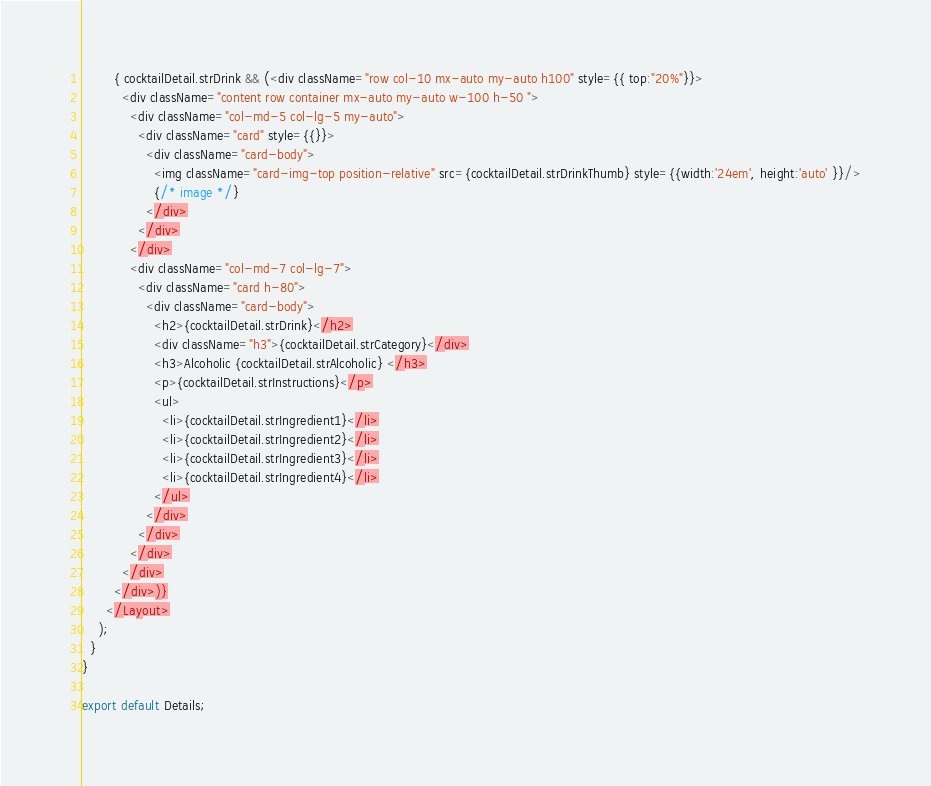<code> <loc_0><loc_0><loc_500><loc_500><_JavaScript_>        { cocktailDetail.strDrink && (<div className="row col-10 mx-auto my-auto h100" style={{ top:"20%"}}>
          <div className="content row container mx-auto my-auto w-100 h-50 ">
            <div className="col-md-5 col-lg-5 my-auto">
              <div className="card" style={{}}>
                <div className="card-body">
                  <img className="card-img-top position-relative" src={cocktailDetail.strDrinkThumb} style={{width:'24em', height:'auto' }}/>
                  {/* image */}
                </div>
              </div>
            </div>
            <div className="col-md-7 col-lg-7">
              <div className="card h-80">
                <div className="card-body">
                  <h2>{cocktailDetail.strDrink}</h2>
                  <div className="h3">{cocktailDetail.strCategory}</div>
                  <h3>Alcoholic {cocktailDetail.strAlcoholic} </h3>
                  <p>{cocktailDetail.strInstructions}</p>
                  <ul>
                    <li>{cocktailDetail.strIngredient1}</li>
                    <li>{cocktailDetail.strIngredient2}</li>
                    <li>{cocktailDetail.strIngredient3}</li>
                    <li>{cocktailDetail.strIngredient4}</li>
                  </ul>
                </div>
              </div>
            </div>
          </div>
        </div>)}
      </Layout>
    );
  }
}

export default Details;
</code> 